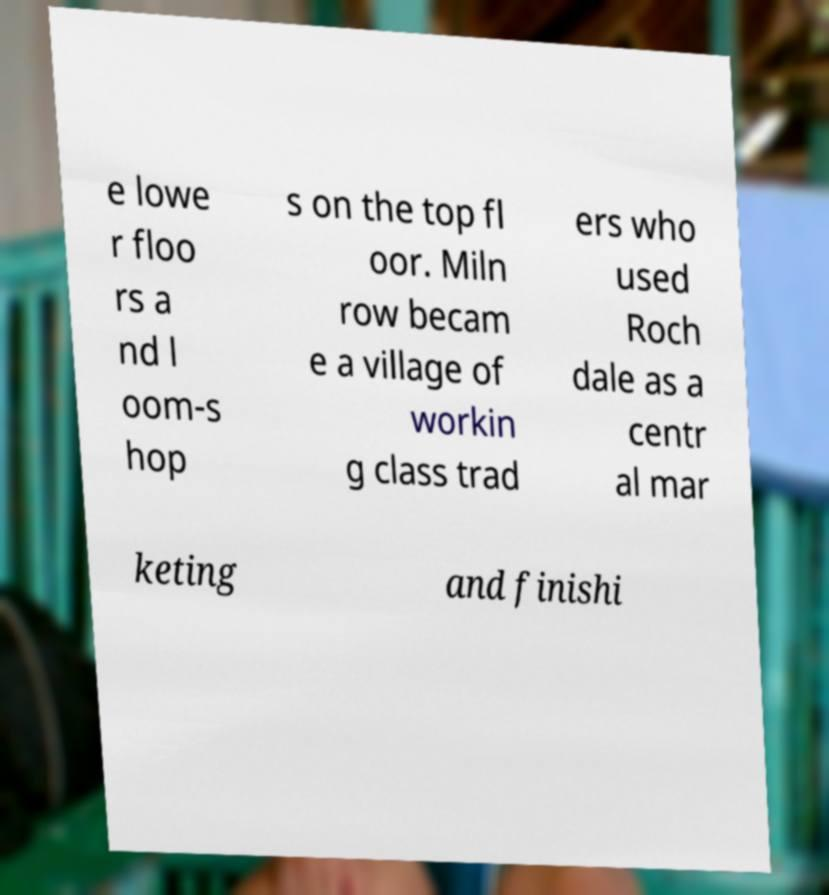I need the written content from this picture converted into text. Can you do that? e lowe r floo rs a nd l oom-s hop s on the top fl oor. Miln row becam e a village of workin g class trad ers who used Roch dale as a centr al mar keting and finishi 